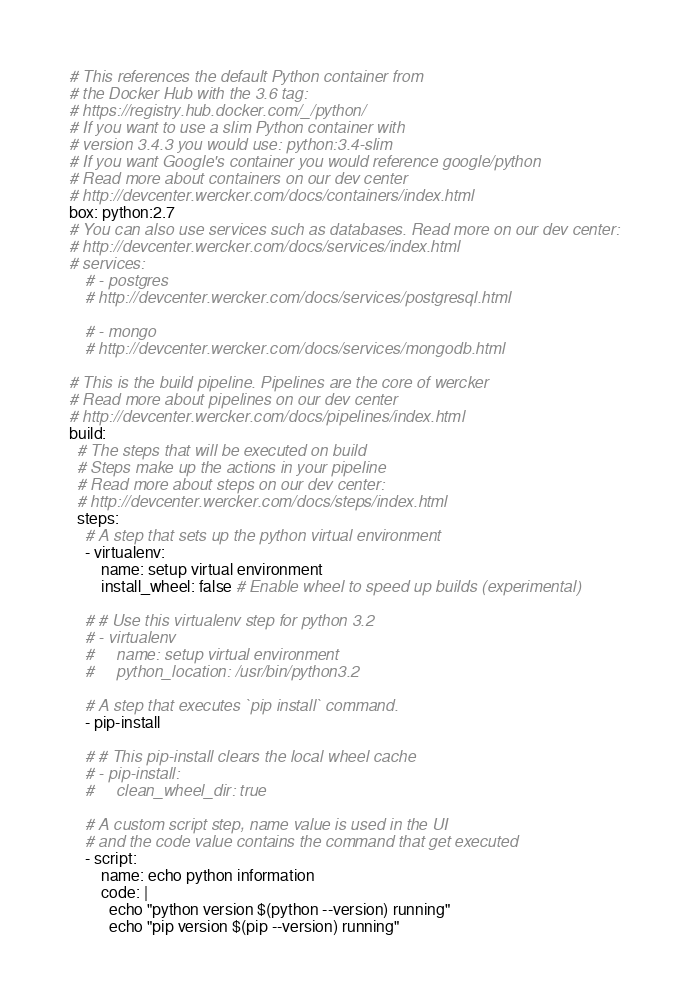Convert code to text. <code><loc_0><loc_0><loc_500><loc_500><_YAML_># This references the default Python container from
# the Docker Hub with the 3.6 tag:
# https://registry.hub.docker.com/_/python/
# If you want to use a slim Python container with
# version 3.4.3 you would use: python:3.4-slim
# If you want Google's container you would reference google/python
# Read more about containers on our dev center
# http://devcenter.wercker.com/docs/containers/index.html
box: python:2.7
# You can also use services such as databases. Read more on our dev center:
# http://devcenter.wercker.com/docs/services/index.html
# services:
    # - postgres
    # http://devcenter.wercker.com/docs/services/postgresql.html

    # - mongo
    # http://devcenter.wercker.com/docs/services/mongodb.html

# This is the build pipeline. Pipelines are the core of wercker
# Read more about pipelines on our dev center
# http://devcenter.wercker.com/docs/pipelines/index.html
build:
  # The steps that will be executed on build
  # Steps make up the actions in your pipeline
  # Read more about steps on our dev center:
  # http://devcenter.wercker.com/docs/steps/index.html
  steps:
    # A step that sets up the python virtual environment
    - virtualenv:
        name: setup virtual environment
        install_wheel: false # Enable wheel to speed up builds (experimental)

    # # Use this virtualenv step for python 3.2
    # - virtualenv
    #     name: setup virtual environment
    #     python_location: /usr/bin/python3.2

    # A step that executes `pip install` command.
    - pip-install

    # # This pip-install clears the local wheel cache
    # - pip-install:
    #     clean_wheel_dir: true

    # A custom script step, name value is used in the UI
    # and the code value contains the command that get executed
    - script:
        name: echo python information
        code: |
          echo "python version $(python --version) running"
          echo "pip version $(pip --version) running"
</code> 